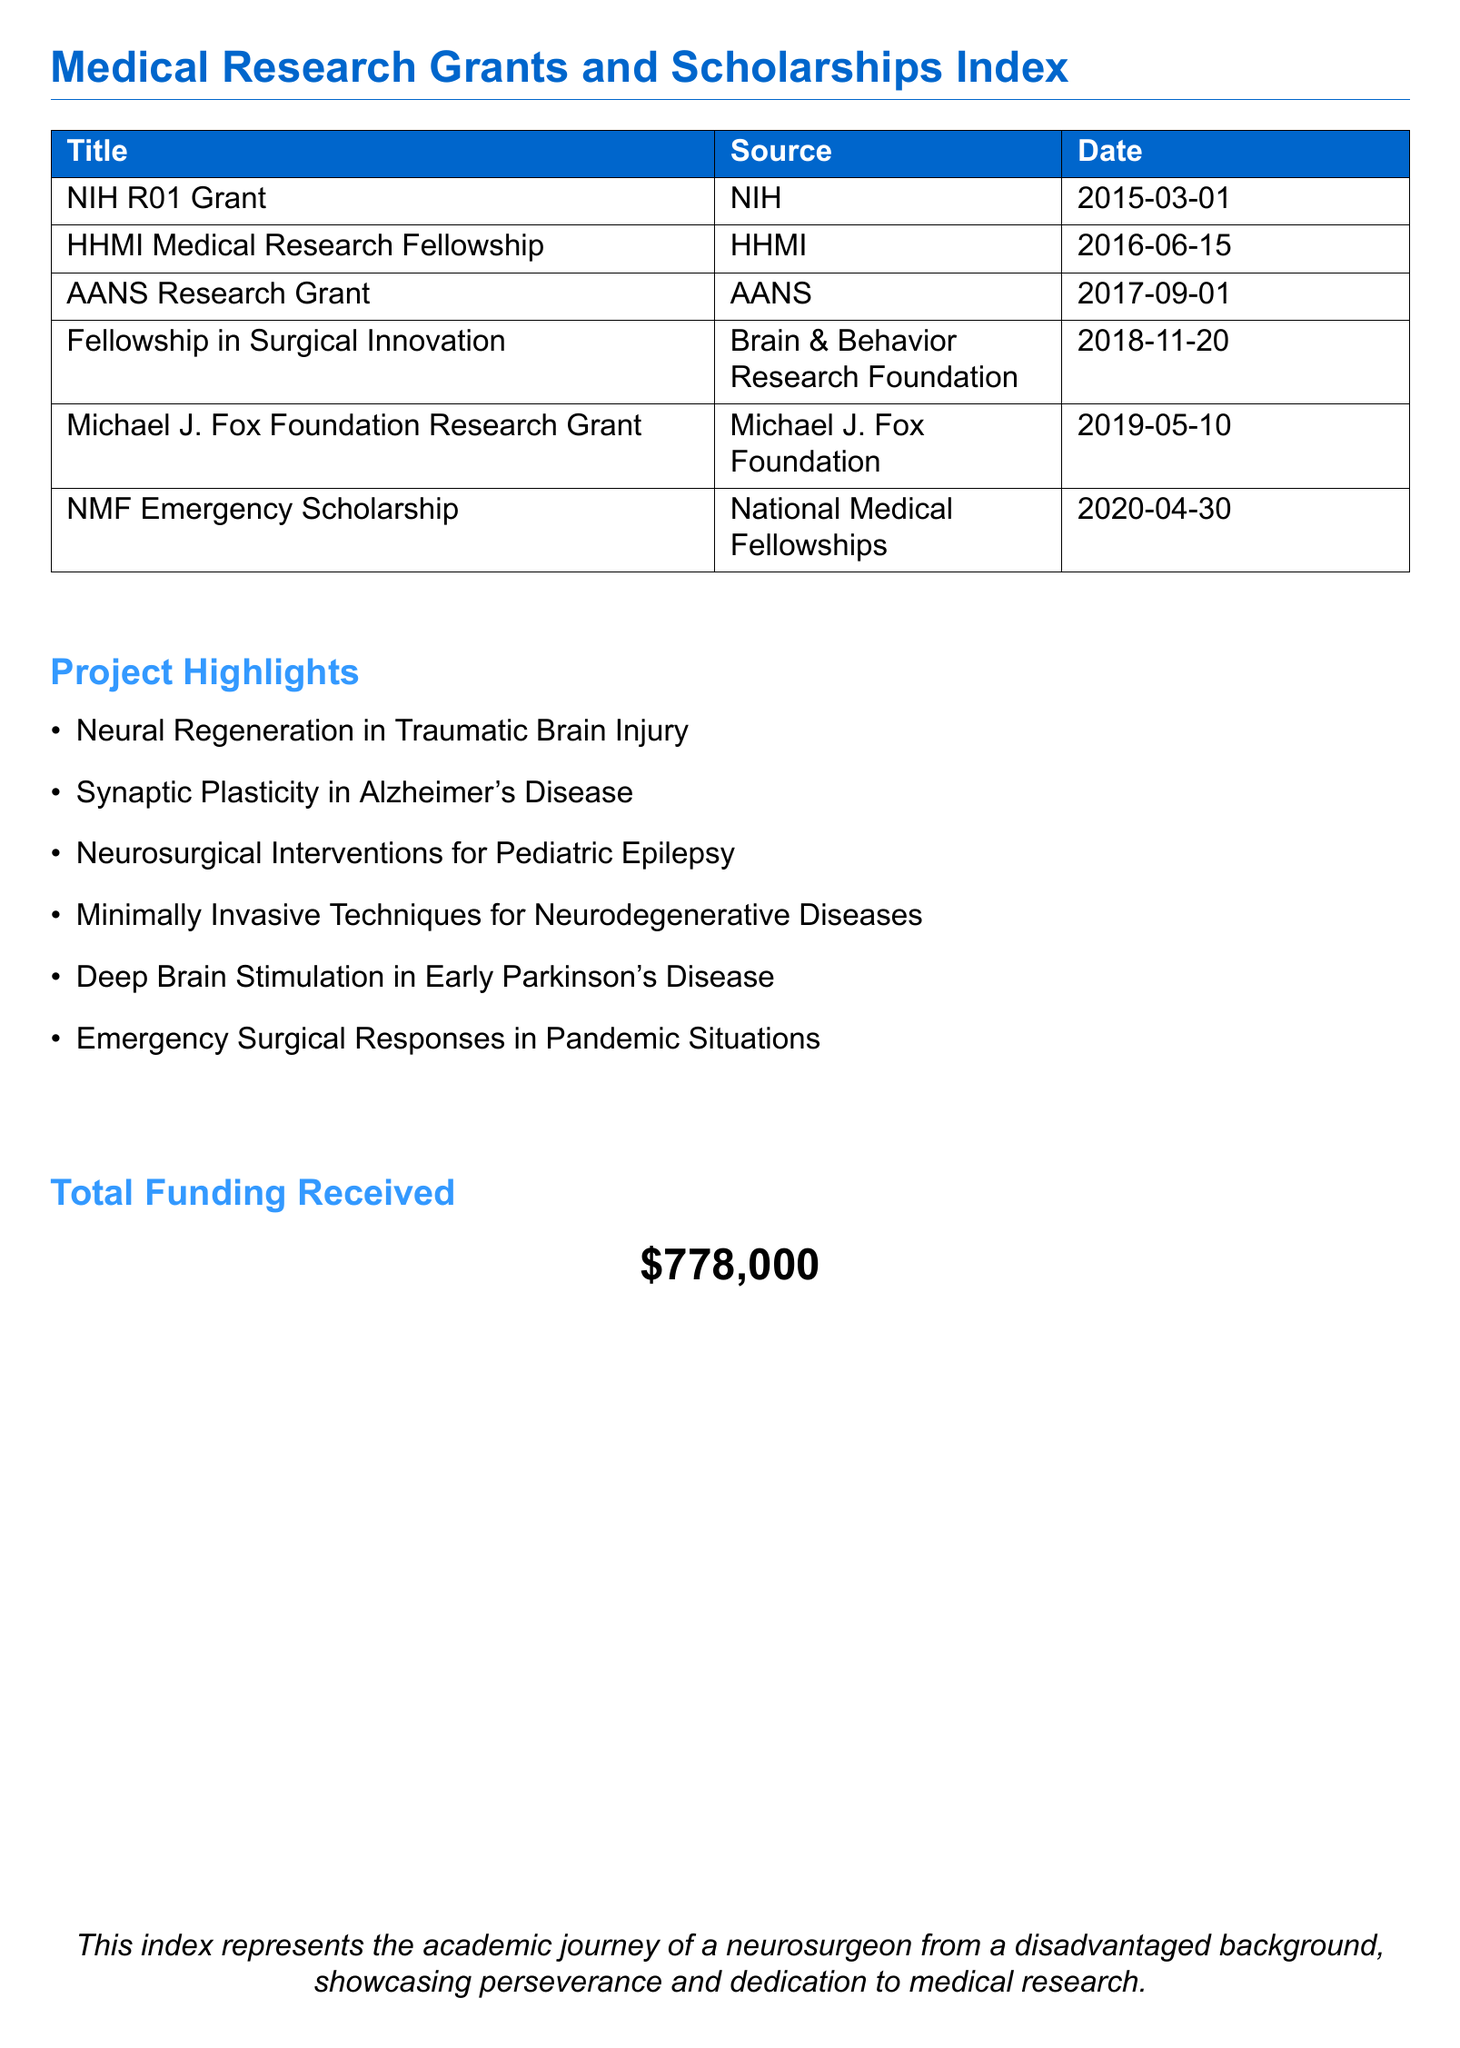What is the total funding received? The total funding received is stated explicitly in the document under "Total Funding Received."
Answer: $778,000 Which organization provided the NIH R01 Grant? The document lists the source of the NIH R01 Grant, which is the NIH.
Answer: NIH When was the Fellowship in Surgical Innovation awarded? The date awarded for the Fellowship in Surgical Innovation is given in the table.
Answer: 2018-11-20 What is one project highlighted in the document? The document specifies several project highlights, and any of them can be a correct answer.
Answer: Neural Regeneration in Traumatic Brain Injury How many total grants and scholarships are listed? The total number of entries in the table indicates how many grants and scholarships are mentioned.
Answer: 6 What is the source for the Michael J. Fox Foundation Research Grant? The table indicates the source for the grant by the Michael J. Fox Foundation.
Answer: Michael J. Fox Foundation Which grant was awarded most recently? The most recent award is noted in the table, requiring a comparison of dates.
Answer: NMF Emergency Scholarship What date was the HHMI Medical Research Fellowship awarded? The specific date for the HHMI Medical Research Fellowship is provided in the table.
Answer: 2016-06-15 What type of document is this? The nature of the document is identified in the title at the beginning.
Answer: Index 